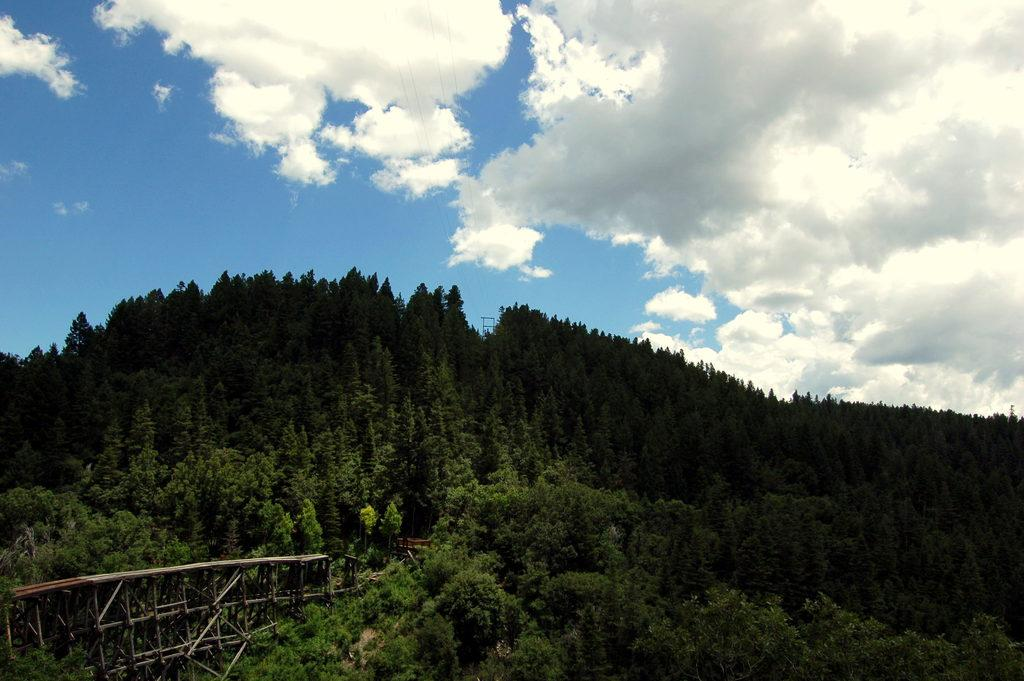What type of vegetation can be seen in the image? There are trees in the image. What structure is present among the trees? There is a wooden bridge in the image. How is the bridge positioned in relation to the trees? The bridge is situated between the trees. What can be seen above the trees in the image? The sky is visible in the image. What is the condition of the sky in the image? Clouds are present in the sky. How many socks are hanging on the trees in the image? There are no socks present in the image; it features trees, a wooden bridge, and a sky with clouds. What type of pigs can be seen interacting with the wooden bridge in the image? There are no pigs present in the image; it features trees, a wooden bridge, and a sky with clouds. 